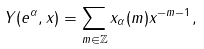<formula> <loc_0><loc_0><loc_500><loc_500>Y ( e ^ { \alpha } , x ) = \sum _ { m \in \mathbb { Z } } x _ { \alpha } ( m ) x ^ { - m - 1 } ,</formula> 